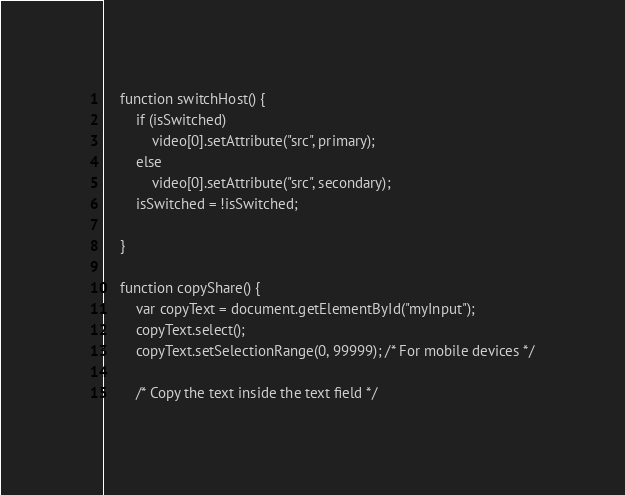<code> <loc_0><loc_0><loc_500><loc_500><_HTML_>    function switchHost() {
        if (isSwitched)
            video[0].setAttribute("src", primary);
        else
            video[0].setAttribute("src", secondary);
        isSwitched = !isSwitched;

    }

    function copyShare() {
        var copyText = document.getElementById("myInput");
        copyText.select();
        copyText.setSelectionRange(0, 99999); /* For mobile devices */

        /* Copy the text inside the text field */</code> 